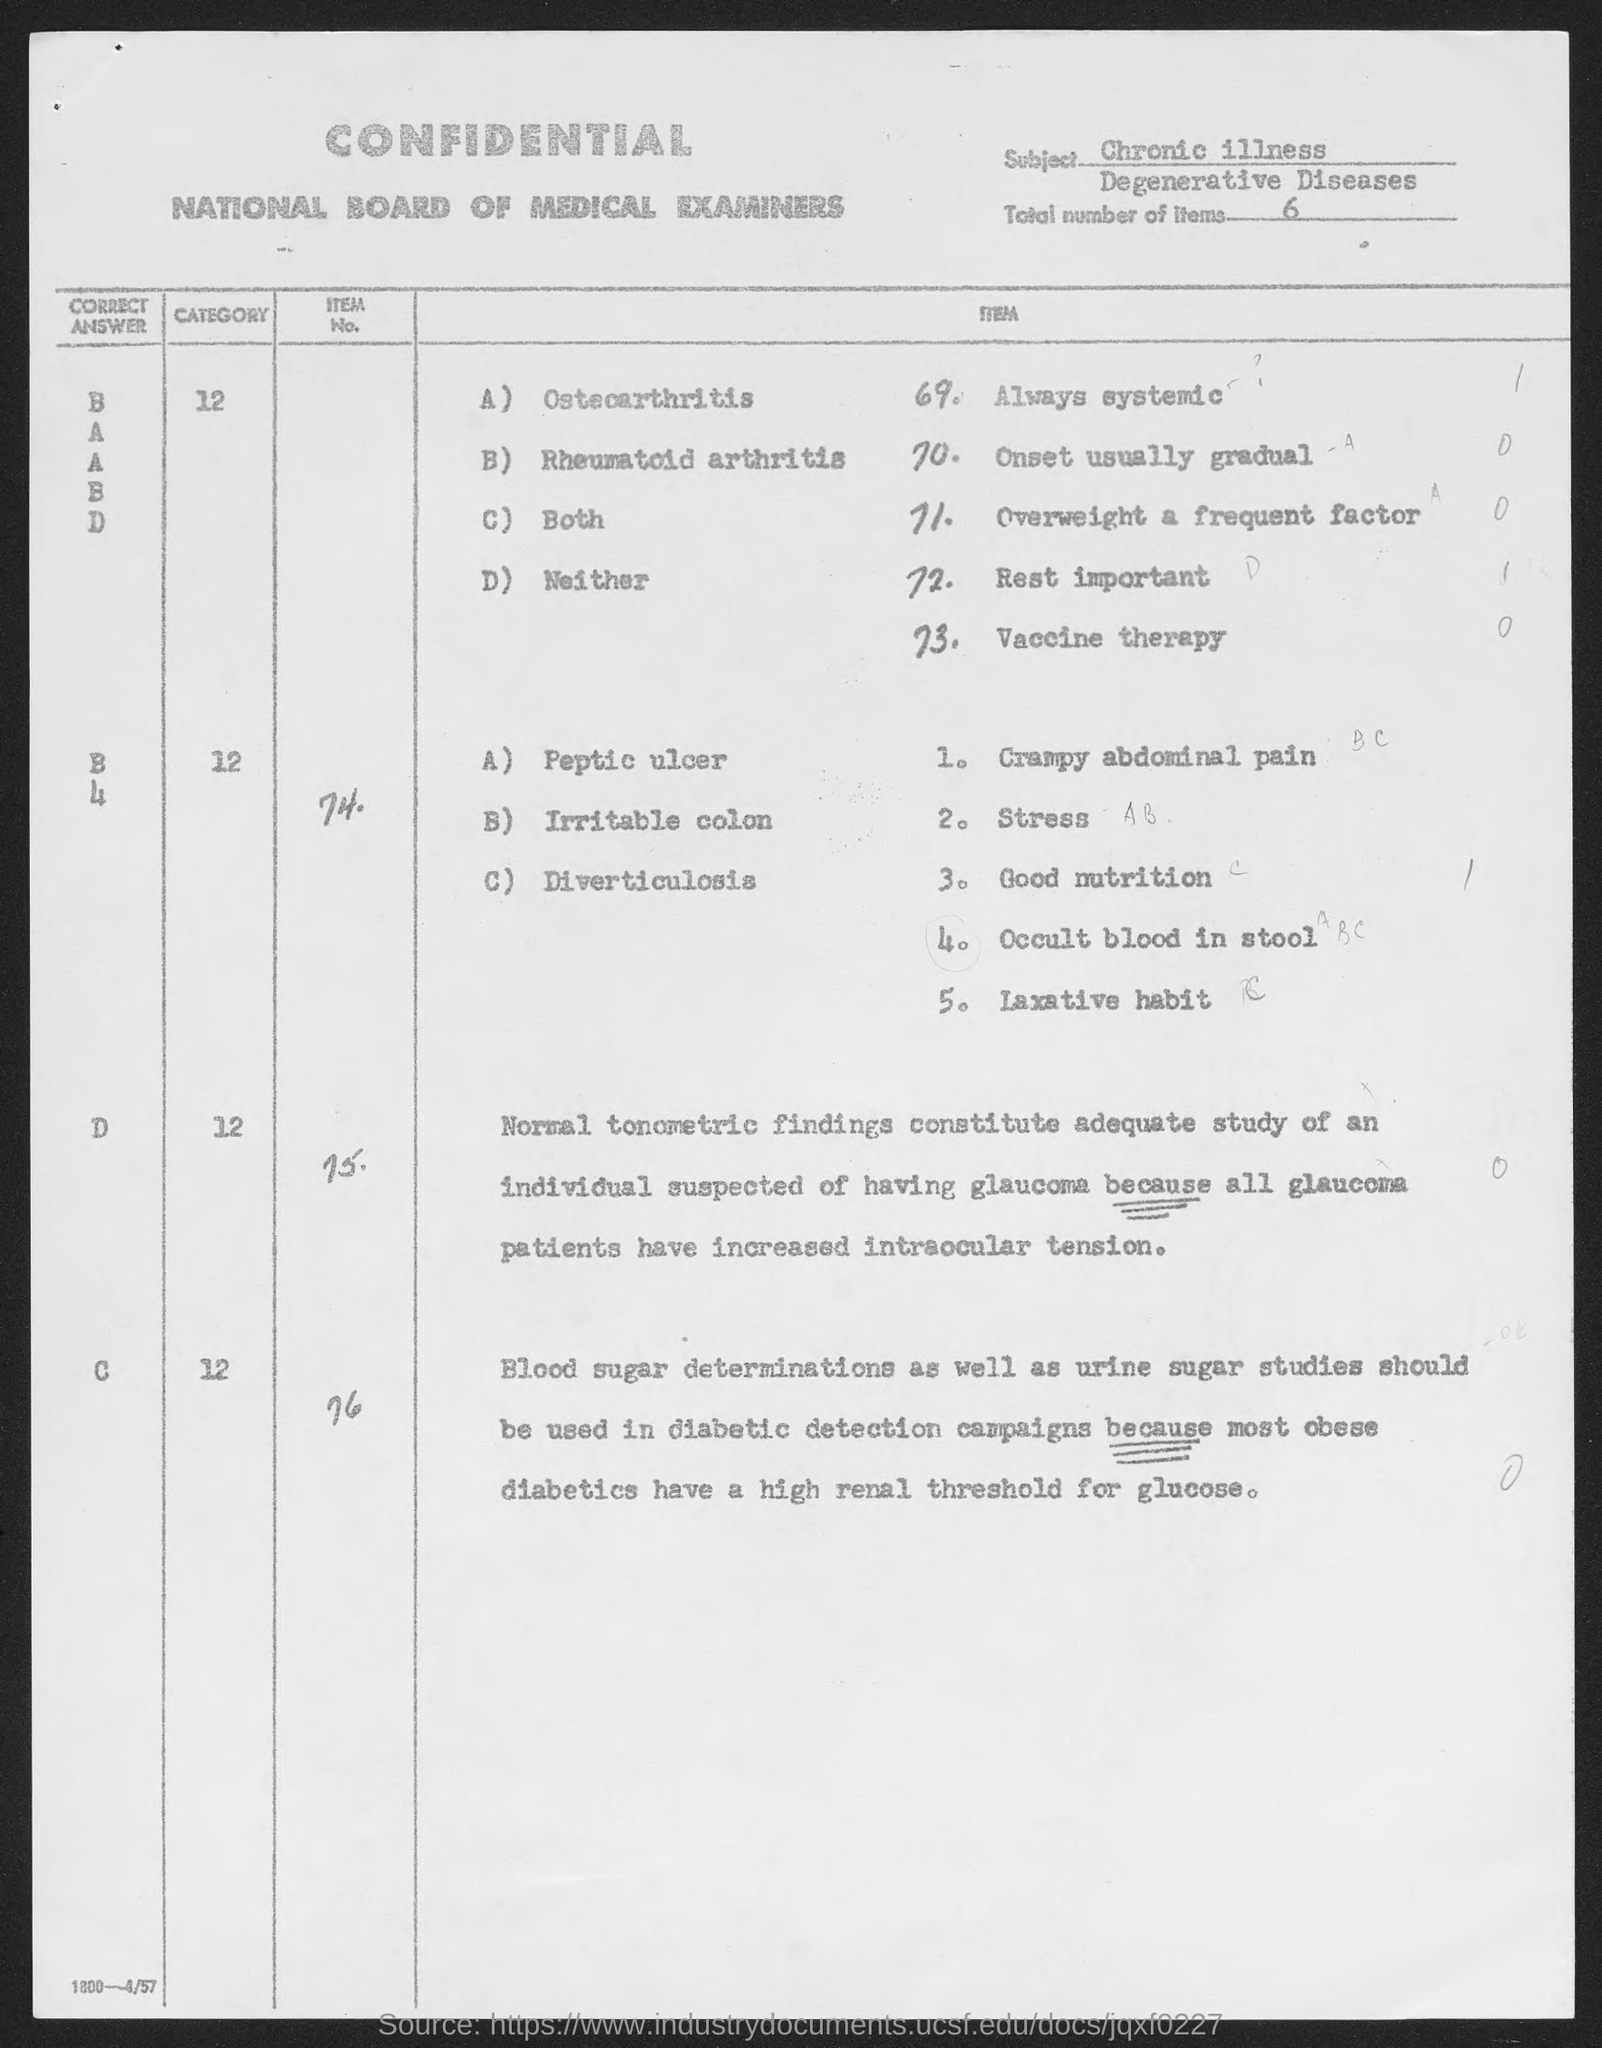Identify some key points in this picture. The subject mentioned in the given page is chronic illness. The given page contains a total of 6 items. 